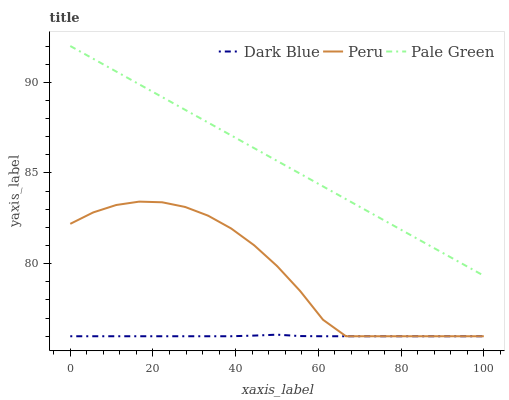Does Dark Blue have the minimum area under the curve?
Answer yes or no. Yes. Does Pale Green have the maximum area under the curve?
Answer yes or no. Yes. Does Peru have the minimum area under the curve?
Answer yes or no. No. Does Peru have the maximum area under the curve?
Answer yes or no. No. Is Pale Green the smoothest?
Answer yes or no. Yes. Is Peru the roughest?
Answer yes or no. Yes. Is Peru the smoothest?
Answer yes or no. No. Is Pale Green the roughest?
Answer yes or no. No. Does Pale Green have the lowest value?
Answer yes or no. No. Does Pale Green have the highest value?
Answer yes or no. Yes. Does Peru have the highest value?
Answer yes or no. No. Is Dark Blue less than Pale Green?
Answer yes or no. Yes. Is Pale Green greater than Peru?
Answer yes or no. Yes. Does Peru intersect Dark Blue?
Answer yes or no. Yes. Is Peru less than Dark Blue?
Answer yes or no. No. Is Peru greater than Dark Blue?
Answer yes or no. No. Does Dark Blue intersect Pale Green?
Answer yes or no. No. 